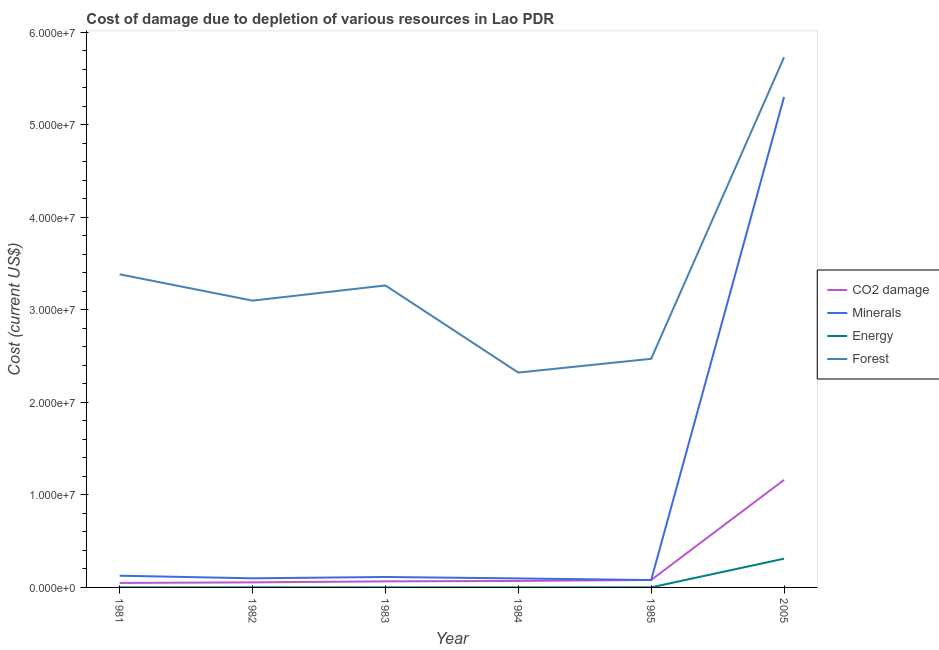How many different coloured lines are there?
Give a very brief answer. 4. Does the line corresponding to cost of damage due to depletion of forests intersect with the line corresponding to cost of damage due to depletion of minerals?
Provide a short and direct response. No. What is the cost of damage due to depletion of minerals in 1985?
Your answer should be very brief. 7.98e+05. Across all years, what is the maximum cost of damage due to depletion of minerals?
Ensure brevity in your answer.  5.30e+07. Across all years, what is the minimum cost of damage due to depletion of minerals?
Give a very brief answer. 7.98e+05. In which year was the cost of damage due to depletion of minerals maximum?
Your answer should be very brief. 2005. In which year was the cost of damage due to depletion of energy minimum?
Your response must be concise. 1981. What is the total cost of damage due to depletion of coal in the graph?
Provide a short and direct response. 1.48e+07. What is the difference between the cost of damage due to depletion of coal in 1984 and that in 2005?
Provide a short and direct response. -1.09e+07. What is the difference between the cost of damage due to depletion of minerals in 1985 and the cost of damage due to depletion of coal in 2005?
Offer a very short reply. -1.08e+07. What is the average cost of damage due to depletion of coal per year?
Offer a terse response. 2.47e+06. In the year 2005, what is the difference between the cost of damage due to depletion of forests and cost of damage due to depletion of coal?
Ensure brevity in your answer.  4.57e+07. What is the ratio of the cost of damage due to depletion of forests in 1983 to that in 1984?
Provide a short and direct response. 1.41. What is the difference between the highest and the second highest cost of damage due to depletion of forests?
Your response must be concise. 2.35e+07. What is the difference between the highest and the lowest cost of damage due to depletion of minerals?
Your response must be concise. 5.22e+07. In how many years, is the cost of damage due to depletion of forests greater than the average cost of damage due to depletion of forests taken over all years?
Offer a terse response. 2. Is the sum of the cost of damage due to depletion of forests in 1985 and 2005 greater than the maximum cost of damage due to depletion of energy across all years?
Your response must be concise. Yes. Is it the case that in every year, the sum of the cost of damage due to depletion of minerals and cost of damage due to depletion of forests is greater than the sum of cost of damage due to depletion of energy and cost of damage due to depletion of coal?
Give a very brief answer. Yes. Does the cost of damage due to depletion of minerals monotonically increase over the years?
Your answer should be very brief. No. Is the cost of damage due to depletion of forests strictly greater than the cost of damage due to depletion of coal over the years?
Give a very brief answer. Yes. How many years are there in the graph?
Give a very brief answer. 6. What is the difference between two consecutive major ticks on the Y-axis?
Your answer should be compact. 1.00e+07. Does the graph contain any zero values?
Your answer should be very brief. No. Where does the legend appear in the graph?
Ensure brevity in your answer.  Center right. How are the legend labels stacked?
Your answer should be very brief. Vertical. What is the title of the graph?
Ensure brevity in your answer.  Cost of damage due to depletion of various resources in Lao PDR . What is the label or title of the X-axis?
Your response must be concise. Year. What is the label or title of the Y-axis?
Provide a succinct answer. Cost (current US$). What is the Cost (current US$) of CO2 damage in 1981?
Your answer should be compact. 4.86e+05. What is the Cost (current US$) of Minerals in 1981?
Provide a succinct answer. 1.27e+06. What is the Cost (current US$) in Energy in 1981?
Offer a very short reply. 1965.83. What is the Cost (current US$) of Forest in 1981?
Offer a very short reply. 3.38e+07. What is the Cost (current US$) in CO2 damage in 1982?
Your response must be concise. 5.48e+05. What is the Cost (current US$) in Minerals in 1982?
Offer a terse response. 9.86e+05. What is the Cost (current US$) of Energy in 1982?
Your answer should be compact. 4233.79. What is the Cost (current US$) in Forest in 1982?
Your answer should be very brief. 3.10e+07. What is the Cost (current US$) in CO2 damage in 1983?
Give a very brief answer. 6.56e+05. What is the Cost (current US$) of Minerals in 1983?
Provide a succinct answer. 1.13e+06. What is the Cost (current US$) of Energy in 1983?
Make the answer very short. 2659.48. What is the Cost (current US$) of Forest in 1983?
Provide a short and direct response. 3.26e+07. What is the Cost (current US$) in CO2 damage in 1984?
Your answer should be very brief. 7.02e+05. What is the Cost (current US$) in Minerals in 1984?
Keep it short and to the point. 9.74e+05. What is the Cost (current US$) of Energy in 1984?
Offer a very short reply. 2016.19. What is the Cost (current US$) in Forest in 1984?
Provide a short and direct response. 2.32e+07. What is the Cost (current US$) of CO2 damage in 1985?
Make the answer very short. 8.06e+05. What is the Cost (current US$) of Minerals in 1985?
Offer a very short reply. 7.98e+05. What is the Cost (current US$) in Energy in 1985?
Provide a succinct answer. 7148.62. What is the Cost (current US$) in Forest in 1985?
Make the answer very short. 2.47e+07. What is the Cost (current US$) of CO2 damage in 2005?
Your answer should be very brief. 1.16e+07. What is the Cost (current US$) in Minerals in 2005?
Provide a short and direct response. 5.30e+07. What is the Cost (current US$) of Energy in 2005?
Your answer should be very brief. 3.11e+06. What is the Cost (current US$) of Forest in 2005?
Make the answer very short. 5.73e+07. Across all years, what is the maximum Cost (current US$) in CO2 damage?
Your answer should be very brief. 1.16e+07. Across all years, what is the maximum Cost (current US$) of Minerals?
Keep it short and to the point. 5.30e+07. Across all years, what is the maximum Cost (current US$) in Energy?
Your response must be concise. 3.11e+06. Across all years, what is the maximum Cost (current US$) of Forest?
Provide a succinct answer. 5.73e+07. Across all years, what is the minimum Cost (current US$) of CO2 damage?
Give a very brief answer. 4.86e+05. Across all years, what is the minimum Cost (current US$) in Minerals?
Keep it short and to the point. 7.98e+05. Across all years, what is the minimum Cost (current US$) in Energy?
Your answer should be compact. 1965.83. Across all years, what is the minimum Cost (current US$) of Forest?
Give a very brief answer. 2.32e+07. What is the total Cost (current US$) of CO2 damage in the graph?
Offer a terse response. 1.48e+07. What is the total Cost (current US$) of Minerals in the graph?
Provide a succinct answer. 5.82e+07. What is the total Cost (current US$) of Energy in the graph?
Your response must be concise. 3.13e+06. What is the total Cost (current US$) in Forest in the graph?
Your response must be concise. 2.03e+08. What is the difference between the Cost (current US$) in CO2 damage in 1981 and that in 1982?
Your response must be concise. -6.17e+04. What is the difference between the Cost (current US$) in Minerals in 1981 and that in 1982?
Ensure brevity in your answer.  2.79e+05. What is the difference between the Cost (current US$) in Energy in 1981 and that in 1982?
Your answer should be compact. -2267.95. What is the difference between the Cost (current US$) of Forest in 1981 and that in 1982?
Offer a terse response. 2.84e+06. What is the difference between the Cost (current US$) of CO2 damage in 1981 and that in 1983?
Your answer should be very brief. -1.70e+05. What is the difference between the Cost (current US$) in Minerals in 1981 and that in 1983?
Your answer should be very brief. 1.36e+05. What is the difference between the Cost (current US$) of Energy in 1981 and that in 1983?
Your answer should be very brief. -693.65. What is the difference between the Cost (current US$) of Forest in 1981 and that in 1983?
Your answer should be very brief. 1.20e+06. What is the difference between the Cost (current US$) in CO2 damage in 1981 and that in 1984?
Your response must be concise. -2.16e+05. What is the difference between the Cost (current US$) in Minerals in 1981 and that in 1984?
Offer a terse response. 2.91e+05. What is the difference between the Cost (current US$) in Energy in 1981 and that in 1984?
Provide a short and direct response. -50.36. What is the difference between the Cost (current US$) in Forest in 1981 and that in 1984?
Your answer should be very brief. 1.06e+07. What is the difference between the Cost (current US$) in CO2 damage in 1981 and that in 1985?
Make the answer very short. -3.20e+05. What is the difference between the Cost (current US$) of Minerals in 1981 and that in 1985?
Your response must be concise. 4.67e+05. What is the difference between the Cost (current US$) in Energy in 1981 and that in 1985?
Keep it short and to the point. -5182.79. What is the difference between the Cost (current US$) of Forest in 1981 and that in 1985?
Make the answer very short. 9.13e+06. What is the difference between the Cost (current US$) in CO2 damage in 1981 and that in 2005?
Make the answer very short. -1.11e+07. What is the difference between the Cost (current US$) in Minerals in 1981 and that in 2005?
Provide a succinct answer. -5.17e+07. What is the difference between the Cost (current US$) of Energy in 1981 and that in 2005?
Offer a terse response. -3.11e+06. What is the difference between the Cost (current US$) in Forest in 1981 and that in 2005?
Your answer should be compact. -2.35e+07. What is the difference between the Cost (current US$) of CO2 damage in 1982 and that in 1983?
Give a very brief answer. -1.09e+05. What is the difference between the Cost (current US$) of Minerals in 1982 and that in 1983?
Offer a very short reply. -1.43e+05. What is the difference between the Cost (current US$) in Energy in 1982 and that in 1983?
Keep it short and to the point. 1574.31. What is the difference between the Cost (current US$) of Forest in 1982 and that in 1983?
Your response must be concise. -1.64e+06. What is the difference between the Cost (current US$) of CO2 damage in 1982 and that in 1984?
Keep it short and to the point. -1.54e+05. What is the difference between the Cost (current US$) of Minerals in 1982 and that in 1984?
Provide a short and direct response. 1.22e+04. What is the difference between the Cost (current US$) of Energy in 1982 and that in 1984?
Keep it short and to the point. 2217.6. What is the difference between the Cost (current US$) of Forest in 1982 and that in 1984?
Your answer should be compact. 7.78e+06. What is the difference between the Cost (current US$) of CO2 damage in 1982 and that in 1985?
Your answer should be very brief. -2.58e+05. What is the difference between the Cost (current US$) of Minerals in 1982 and that in 1985?
Ensure brevity in your answer.  1.88e+05. What is the difference between the Cost (current US$) of Energy in 1982 and that in 1985?
Give a very brief answer. -2914.84. What is the difference between the Cost (current US$) in Forest in 1982 and that in 1985?
Provide a short and direct response. 6.29e+06. What is the difference between the Cost (current US$) of CO2 damage in 1982 and that in 2005?
Provide a short and direct response. -1.11e+07. What is the difference between the Cost (current US$) of Minerals in 1982 and that in 2005?
Offer a terse response. -5.20e+07. What is the difference between the Cost (current US$) of Energy in 1982 and that in 2005?
Provide a short and direct response. -3.10e+06. What is the difference between the Cost (current US$) of Forest in 1982 and that in 2005?
Make the answer very short. -2.63e+07. What is the difference between the Cost (current US$) of CO2 damage in 1983 and that in 1984?
Provide a short and direct response. -4.53e+04. What is the difference between the Cost (current US$) in Minerals in 1983 and that in 1984?
Your answer should be compact. 1.55e+05. What is the difference between the Cost (current US$) in Energy in 1983 and that in 1984?
Make the answer very short. 643.29. What is the difference between the Cost (current US$) in Forest in 1983 and that in 1984?
Provide a succinct answer. 9.42e+06. What is the difference between the Cost (current US$) of CO2 damage in 1983 and that in 1985?
Ensure brevity in your answer.  -1.50e+05. What is the difference between the Cost (current US$) in Minerals in 1983 and that in 1985?
Your answer should be compact. 3.31e+05. What is the difference between the Cost (current US$) in Energy in 1983 and that in 1985?
Make the answer very short. -4489.14. What is the difference between the Cost (current US$) in Forest in 1983 and that in 1985?
Give a very brief answer. 7.93e+06. What is the difference between the Cost (current US$) of CO2 damage in 1983 and that in 2005?
Give a very brief answer. -1.10e+07. What is the difference between the Cost (current US$) in Minerals in 1983 and that in 2005?
Offer a terse response. -5.19e+07. What is the difference between the Cost (current US$) of Energy in 1983 and that in 2005?
Your answer should be compact. -3.10e+06. What is the difference between the Cost (current US$) of Forest in 1983 and that in 2005?
Offer a terse response. -2.47e+07. What is the difference between the Cost (current US$) in CO2 damage in 1984 and that in 1985?
Your answer should be compact. -1.04e+05. What is the difference between the Cost (current US$) of Minerals in 1984 and that in 1985?
Give a very brief answer. 1.76e+05. What is the difference between the Cost (current US$) of Energy in 1984 and that in 1985?
Your answer should be compact. -5132.43. What is the difference between the Cost (current US$) in Forest in 1984 and that in 1985?
Give a very brief answer. -1.49e+06. What is the difference between the Cost (current US$) in CO2 damage in 1984 and that in 2005?
Keep it short and to the point. -1.09e+07. What is the difference between the Cost (current US$) in Minerals in 1984 and that in 2005?
Keep it short and to the point. -5.20e+07. What is the difference between the Cost (current US$) of Energy in 1984 and that in 2005?
Provide a succinct answer. -3.11e+06. What is the difference between the Cost (current US$) of Forest in 1984 and that in 2005?
Provide a succinct answer. -3.41e+07. What is the difference between the Cost (current US$) in CO2 damage in 1985 and that in 2005?
Keep it short and to the point. -1.08e+07. What is the difference between the Cost (current US$) of Minerals in 1985 and that in 2005?
Your response must be concise. -5.22e+07. What is the difference between the Cost (current US$) in Energy in 1985 and that in 2005?
Your answer should be compact. -3.10e+06. What is the difference between the Cost (current US$) of Forest in 1985 and that in 2005?
Offer a terse response. -3.26e+07. What is the difference between the Cost (current US$) in CO2 damage in 1981 and the Cost (current US$) in Minerals in 1982?
Offer a very short reply. -5.00e+05. What is the difference between the Cost (current US$) in CO2 damage in 1981 and the Cost (current US$) in Energy in 1982?
Your answer should be compact. 4.82e+05. What is the difference between the Cost (current US$) in CO2 damage in 1981 and the Cost (current US$) in Forest in 1982?
Your answer should be compact. -3.05e+07. What is the difference between the Cost (current US$) in Minerals in 1981 and the Cost (current US$) in Energy in 1982?
Your answer should be very brief. 1.26e+06. What is the difference between the Cost (current US$) in Minerals in 1981 and the Cost (current US$) in Forest in 1982?
Keep it short and to the point. -2.97e+07. What is the difference between the Cost (current US$) of Energy in 1981 and the Cost (current US$) of Forest in 1982?
Offer a terse response. -3.10e+07. What is the difference between the Cost (current US$) in CO2 damage in 1981 and the Cost (current US$) in Minerals in 1983?
Provide a succinct answer. -6.43e+05. What is the difference between the Cost (current US$) in CO2 damage in 1981 and the Cost (current US$) in Energy in 1983?
Your answer should be compact. 4.83e+05. What is the difference between the Cost (current US$) in CO2 damage in 1981 and the Cost (current US$) in Forest in 1983?
Your answer should be compact. -3.22e+07. What is the difference between the Cost (current US$) of Minerals in 1981 and the Cost (current US$) of Energy in 1983?
Your answer should be very brief. 1.26e+06. What is the difference between the Cost (current US$) in Minerals in 1981 and the Cost (current US$) in Forest in 1983?
Your answer should be compact. -3.14e+07. What is the difference between the Cost (current US$) in Energy in 1981 and the Cost (current US$) in Forest in 1983?
Make the answer very short. -3.26e+07. What is the difference between the Cost (current US$) of CO2 damage in 1981 and the Cost (current US$) of Minerals in 1984?
Give a very brief answer. -4.88e+05. What is the difference between the Cost (current US$) of CO2 damage in 1981 and the Cost (current US$) of Energy in 1984?
Keep it short and to the point. 4.84e+05. What is the difference between the Cost (current US$) of CO2 damage in 1981 and the Cost (current US$) of Forest in 1984?
Your answer should be very brief. -2.27e+07. What is the difference between the Cost (current US$) in Minerals in 1981 and the Cost (current US$) in Energy in 1984?
Your answer should be very brief. 1.26e+06. What is the difference between the Cost (current US$) in Minerals in 1981 and the Cost (current US$) in Forest in 1984?
Offer a terse response. -2.20e+07. What is the difference between the Cost (current US$) of Energy in 1981 and the Cost (current US$) of Forest in 1984?
Keep it short and to the point. -2.32e+07. What is the difference between the Cost (current US$) in CO2 damage in 1981 and the Cost (current US$) in Minerals in 1985?
Offer a terse response. -3.12e+05. What is the difference between the Cost (current US$) in CO2 damage in 1981 and the Cost (current US$) in Energy in 1985?
Offer a terse response. 4.79e+05. What is the difference between the Cost (current US$) in CO2 damage in 1981 and the Cost (current US$) in Forest in 1985?
Ensure brevity in your answer.  -2.42e+07. What is the difference between the Cost (current US$) of Minerals in 1981 and the Cost (current US$) of Energy in 1985?
Provide a succinct answer. 1.26e+06. What is the difference between the Cost (current US$) of Minerals in 1981 and the Cost (current US$) of Forest in 1985?
Ensure brevity in your answer.  -2.34e+07. What is the difference between the Cost (current US$) in Energy in 1981 and the Cost (current US$) in Forest in 1985?
Your answer should be very brief. -2.47e+07. What is the difference between the Cost (current US$) of CO2 damage in 1981 and the Cost (current US$) of Minerals in 2005?
Your answer should be compact. -5.25e+07. What is the difference between the Cost (current US$) in CO2 damage in 1981 and the Cost (current US$) in Energy in 2005?
Your response must be concise. -2.62e+06. What is the difference between the Cost (current US$) in CO2 damage in 1981 and the Cost (current US$) in Forest in 2005?
Ensure brevity in your answer.  -5.68e+07. What is the difference between the Cost (current US$) of Minerals in 1981 and the Cost (current US$) of Energy in 2005?
Provide a short and direct response. -1.84e+06. What is the difference between the Cost (current US$) in Minerals in 1981 and the Cost (current US$) in Forest in 2005?
Offer a very short reply. -5.60e+07. What is the difference between the Cost (current US$) of Energy in 1981 and the Cost (current US$) of Forest in 2005?
Your response must be concise. -5.73e+07. What is the difference between the Cost (current US$) in CO2 damage in 1982 and the Cost (current US$) in Minerals in 1983?
Provide a succinct answer. -5.81e+05. What is the difference between the Cost (current US$) in CO2 damage in 1982 and the Cost (current US$) in Energy in 1983?
Your answer should be compact. 5.45e+05. What is the difference between the Cost (current US$) of CO2 damage in 1982 and the Cost (current US$) of Forest in 1983?
Ensure brevity in your answer.  -3.21e+07. What is the difference between the Cost (current US$) in Minerals in 1982 and the Cost (current US$) in Energy in 1983?
Provide a short and direct response. 9.83e+05. What is the difference between the Cost (current US$) in Minerals in 1982 and the Cost (current US$) in Forest in 1983?
Provide a short and direct response. -3.17e+07. What is the difference between the Cost (current US$) in Energy in 1982 and the Cost (current US$) in Forest in 1983?
Your answer should be very brief. -3.26e+07. What is the difference between the Cost (current US$) in CO2 damage in 1982 and the Cost (current US$) in Minerals in 1984?
Your answer should be very brief. -4.26e+05. What is the difference between the Cost (current US$) in CO2 damage in 1982 and the Cost (current US$) in Energy in 1984?
Your answer should be very brief. 5.46e+05. What is the difference between the Cost (current US$) in CO2 damage in 1982 and the Cost (current US$) in Forest in 1984?
Give a very brief answer. -2.27e+07. What is the difference between the Cost (current US$) in Minerals in 1982 and the Cost (current US$) in Energy in 1984?
Offer a terse response. 9.84e+05. What is the difference between the Cost (current US$) in Minerals in 1982 and the Cost (current US$) in Forest in 1984?
Your answer should be very brief. -2.22e+07. What is the difference between the Cost (current US$) in Energy in 1982 and the Cost (current US$) in Forest in 1984?
Give a very brief answer. -2.32e+07. What is the difference between the Cost (current US$) of CO2 damage in 1982 and the Cost (current US$) of Minerals in 1985?
Your answer should be compact. -2.50e+05. What is the difference between the Cost (current US$) in CO2 damage in 1982 and the Cost (current US$) in Energy in 1985?
Give a very brief answer. 5.40e+05. What is the difference between the Cost (current US$) of CO2 damage in 1982 and the Cost (current US$) of Forest in 1985?
Keep it short and to the point. -2.42e+07. What is the difference between the Cost (current US$) in Minerals in 1982 and the Cost (current US$) in Energy in 1985?
Give a very brief answer. 9.79e+05. What is the difference between the Cost (current US$) of Minerals in 1982 and the Cost (current US$) of Forest in 1985?
Keep it short and to the point. -2.37e+07. What is the difference between the Cost (current US$) of Energy in 1982 and the Cost (current US$) of Forest in 1985?
Keep it short and to the point. -2.47e+07. What is the difference between the Cost (current US$) in CO2 damage in 1982 and the Cost (current US$) in Minerals in 2005?
Offer a very short reply. -5.25e+07. What is the difference between the Cost (current US$) in CO2 damage in 1982 and the Cost (current US$) in Energy in 2005?
Provide a short and direct response. -2.56e+06. What is the difference between the Cost (current US$) in CO2 damage in 1982 and the Cost (current US$) in Forest in 2005?
Offer a terse response. -5.68e+07. What is the difference between the Cost (current US$) of Minerals in 1982 and the Cost (current US$) of Energy in 2005?
Your answer should be very brief. -2.12e+06. What is the difference between the Cost (current US$) of Minerals in 1982 and the Cost (current US$) of Forest in 2005?
Offer a terse response. -5.63e+07. What is the difference between the Cost (current US$) in Energy in 1982 and the Cost (current US$) in Forest in 2005?
Offer a very short reply. -5.73e+07. What is the difference between the Cost (current US$) of CO2 damage in 1983 and the Cost (current US$) of Minerals in 1984?
Provide a short and direct response. -3.17e+05. What is the difference between the Cost (current US$) in CO2 damage in 1983 and the Cost (current US$) in Energy in 1984?
Provide a short and direct response. 6.54e+05. What is the difference between the Cost (current US$) of CO2 damage in 1983 and the Cost (current US$) of Forest in 1984?
Offer a very short reply. -2.26e+07. What is the difference between the Cost (current US$) in Minerals in 1983 and the Cost (current US$) in Energy in 1984?
Provide a succinct answer. 1.13e+06. What is the difference between the Cost (current US$) in Minerals in 1983 and the Cost (current US$) in Forest in 1984?
Provide a succinct answer. -2.21e+07. What is the difference between the Cost (current US$) of Energy in 1983 and the Cost (current US$) of Forest in 1984?
Ensure brevity in your answer.  -2.32e+07. What is the difference between the Cost (current US$) in CO2 damage in 1983 and the Cost (current US$) in Minerals in 1985?
Offer a terse response. -1.41e+05. What is the difference between the Cost (current US$) in CO2 damage in 1983 and the Cost (current US$) in Energy in 1985?
Give a very brief answer. 6.49e+05. What is the difference between the Cost (current US$) in CO2 damage in 1983 and the Cost (current US$) in Forest in 1985?
Your answer should be compact. -2.41e+07. What is the difference between the Cost (current US$) of Minerals in 1983 and the Cost (current US$) of Energy in 1985?
Provide a short and direct response. 1.12e+06. What is the difference between the Cost (current US$) of Minerals in 1983 and the Cost (current US$) of Forest in 1985?
Provide a short and direct response. -2.36e+07. What is the difference between the Cost (current US$) of Energy in 1983 and the Cost (current US$) of Forest in 1985?
Make the answer very short. -2.47e+07. What is the difference between the Cost (current US$) of CO2 damage in 1983 and the Cost (current US$) of Minerals in 2005?
Offer a terse response. -5.24e+07. What is the difference between the Cost (current US$) of CO2 damage in 1983 and the Cost (current US$) of Energy in 2005?
Your response must be concise. -2.45e+06. What is the difference between the Cost (current US$) of CO2 damage in 1983 and the Cost (current US$) of Forest in 2005?
Provide a short and direct response. -5.66e+07. What is the difference between the Cost (current US$) of Minerals in 1983 and the Cost (current US$) of Energy in 2005?
Give a very brief answer. -1.98e+06. What is the difference between the Cost (current US$) in Minerals in 1983 and the Cost (current US$) in Forest in 2005?
Your answer should be compact. -5.62e+07. What is the difference between the Cost (current US$) of Energy in 1983 and the Cost (current US$) of Forest in 2005?
Provide a succinct answer. -5.73e+07. What is the difference between the Cost (current US$) of CO2 damage in 1984 and the Cost (current US$) of Minerals in 1985?
Your answer should be very brief. -9.61e+04. What is the difference between the Cost (current US$) in CO2 damage in 1984 and the Cost (current US$) in Energy in 1985?
Provide a succinct answer. 6.94e+05. What is the difference between the Cost (current US$) of CO2 damage in 1984 and the Cost (current US$) of Forest in 1985?
Provide a succinct answer. -2.40e+07. What is the difference between the Cost (current US$) of Minerals in 1984 and the Cost (current US$) of Energy in 1985?
Offer a very short reply. 9.67e+05. What is the difference between the Cost (current US$) in Minerals in 1984 and the Cost (current US$) in Forest in 1985?
Your answer should be compact. -2.37e+07. What is the difference between the Cost (current US$) in Energy in 1984 and the Cost (current US$) in Forest in 1985?
Your response must be concise. -2.47e+07. What is the difference between the Cost (current US$) of CO2 damage in 1984 and the Cost (current US$) of Minerals in 2005?
Offer a very short reply. -5.23e+07. What is the difference between the Cost (current US$) in CO2 damage in 1984 and the Cost (current US$) in Energy in 2005?
Keep it short and to the point. -2.41e+06. What is the difference between the Cost (current US$) in CO2 damage in 1984 and the Cost (current US$) in Forest in 2005?
Ensure brevity in your answer.  -5.66e+07. What is the difference between the Cost (current US$) in Minerals in 1984 and the Cost (current US$) in Energy in 2005?
Provide a succinct answer. -2.13e+06. What is the difference between the Cost (current US$) of Minerals in 1984 and the Cost (current US$) of Forest in 2005?
Your response must be concise. -5.63e+07. What is the difference between the Cost (current US$) of Energy in 1984 and the Cost (current US$) of Forest in 2005?
Your answer should be compact. -5.73e+07. What is the difference between the Cost (current US$) of CO2 damage in 1985 and the Cost (current US$) of Minerals in 2005?
Your answer should be compact. -5.22e+07. What is the difference between the Cost (current US$) in CO2 damage in 1985 and the Cost (current US$) in Energy in 2005?
Make the answer very short. -2.30e+06. What is the difference between the Cost (current US$) of CO2 damage in 1985 and the Cost (current US$) of Forest in 2005?
Make the answer very short. -5.65e+07. What is the difference between the Cost (current US$) in Minerals in 1985 and the Cost (current US$) in Energy in 2005?
Offer a terse response. -2.31e+06. What is the difference between the Cost (current US$) in Minerals in 1985 and the Cost (current US$) in Forest in 2005?
Ensure brevity in your answer.  -5.65e+07. What is the difference between the Cost (current US$) in Energy in 1985 and the Cost (current US$) in Forest in 2005?
Provide a short and direct response. -5.73e+07. What is the average Cost (current US$) in CO2 damage per year?
Ensure brevity in your answer.  2.47e+06. What is the average Cost (current US$) of Minerals per year?
Keep it short and to the point. 9.69e+06. What is the average Cost (current US$) in Energy per year?
Your answer should be very brief. 5.21e+05. What is the average Cost (current US$) in Forest per year?
Provide a succinct answer. 3.38e+07. In the year 1981, what is the difference between the Cost (current US$) in CO2 damage and Cost (current US$) in Minerals?
Provide a succinct answer. -7.79e+05. In the year 1981, what is the difference between the Cost (current US$) in CO2 damage and Cost (current US$) in Energy?
Keep it short and to the point. 4.84e+05. In the year 1981, what is the difference between the Cost (current US$) in CO2 damage and Cost (current US$) in Forest?
Give a very brief answer. -3.34e+07. In the year 1981, what is the difference between the Cost (current US$) of Minerals and Cost (current US$) of Energy?
Keep it short and to the point. 1.26e+06. In the year 1981, what is the difference between the Cost (current US$) in Minerals and Cost (current US$) in Forest?
Provide a short and direct response. -3.26e+07. In the year 1981, what is the difference between the Cost (current US$) in Energy and Cost (current US$) in Forest?
Provide a short and direct response. -3.38e+07. In the year 1982, what is the difference between the Cost (current US$) in CO2 damage and Cost (current US$) in Minerals?
Make the answer very short. -4.38e+05. In the year 1982, what is the difference between the Cost (current US$) of CO2 damage and Cost (current US$) of Energy?
Offer a very short reply. 5.43e+05. In the year 1982, what is the difference between the Cost (current US$) in CO2 damage and Cost (current US$) in Forest?
Provide a succinct answer. -3.05e+07. In the year 1982, what is the difference between the Cost (current US$) in Minerals and Cost (current US$) in Energy?
Offer a terse response. 9.82e+05. In the year 1982, what is the difference between the Cost (current US$) of Minerals and Cost (current US$) of Forest?
Offer a terse response. -3.00e+07. In the year 1982, what is the difference between the Cost (current US$) in Energy and Cost (current US$) in Forest?
Your response must be concise. -3.10e+07. In the year 1983, what is the difference between the Cost (current US$) in CO2 damage and Cost (current US$) in Minerals?
Provide a short and direct response. -4.73e+05. In the year 1983, what is the difference between the Cost (current US$) of CO2 damage and Cost (current US$) of Energy?
Offer a very short reply. 6.54e+05. In the year 1983, what is the difference between the Cost (current US$) of CO2 damage and Cost (current US$) of Forest?
Make the answer very short. -3.20e+07. In the year 1983, what is the difference between the Cost (current US$) in Minerals and Cost (current US$) in Energy?
Offer a terse response. 1.13e+06. In the year 1983, what is the difference between the Cost (current US$) of Minerals and Cost (current US$) of Forest?
Keep it short and to the point. -3.15e+07. In the year 1983, what is the difference between the Cost (current US$) in Energy and Cost (current US$) in Forest?
Your answer should be compact. -3.26e+07. In the year 1984, what is the difference between the Cost (current US$) in CO2 damage and Cost (current US$) in Minerals?
Offer a very short reply. -2.72e+05. In the year 1984, what is the difference between the Cost (current US$) in CO2 damage and Cost (current US$) in Energy?
Your answer should be compact. 7.00e+05. In the year 1984, what is the difference between the Cost (current US$) of CO2 damage and Cost (current US$) of Forest?
Provide a short and direct response. -2.25e+07. In the year 1984, what is the difference between the Cost (current US$) of Minerals and Cost (current US$) of Energy?
Your answer should be very brief. 9.72e+05. In the year 1984, what is the difference between the Cost (current US$) in Minerals and Cost (current US$) in Forest?
Your response must be concise. -2.23e+07. In the year 1984, what is the difference between the Cost (current US$) in Energy and Cost (current US$) in Forest?
Give a very brief answer. -2.32e+07. In the year 1985, what is the difference between the Cost (current US$) in CO2 damage and Cost (current US$) in Minerals?
Your answer should be compact. 8139.44. In the year 1985, what is the difference between the Cost (current US$) in CO2 damage and Cost (current US$) in Energy?
Provide a succinct answer. 7.99e+05. In the year 1985, what is the difference between the Cost (current US$) in CO2 damage and Cost (current US$) in Forest?
Keep it short and to the point. -2.39e+07. In the year 1985, what is the difference between the Cost (current US$) in Minerals and Cost (current US$) in Energy?
Give a very brief answer. 7.91e+05. In the year 1985, what is the difference between the Cost (current US$) of Minerals and Cost (current US$) of Forest?
Your answer should be very brief. -2.39e+07. In the year 1985, what is the difference between the Cost (current US$) in Energy and Cost (current US$) in Forest?
Your answer should be very brief. -2.47e+07. In the year 2005, what is the difference between the Cost (current US$) in CO2 damage and Cost (current US$) in Minerals?
Offer a very short reply. -4.14e+07. In the year 2005, what is the difference between the Cost (current US$) in CO2 damage and Cost (current US$) in Energy?
Keep it short and to the point. 8.51e+06. In the year 2005, what is the difference between the Cost (current US$) in CO2 damage and Cost (current US$) in Forest?
Provide a succinct answer. -4.57e+07. In the year 2005, what is the difference between the Cost (current US$) of Minerals and Cost (current US$) of Energy?
Your answer should be very brief. 4.99e+07. In the year 2005, what is the difference between the Cost (current US$) of Minerals and Cost (current US$) of Forest?
Ensure brevity in your answer.  -4.29e+06. In the year 2005, what is the difference between the Cost (current US$) of Energy and Cost (current US$) of Forest?
Provide a short and direct response. -5.42e+07. What is the ratio of the Cost (current US$) in CO2 damage in 1981 to that in 1982?
Keep it short and to the point. 0.89. What is the ratio of the Cost (current US$) of Minerals in 1981 to that in 1982?
Your answer should be very brief. 1.28. What is the ratio of the Cost (current US$) of Energy in 1981 to that in 1982?
Offer a very short reply. 0.46. What is the ratio of the Cost (current US$) in Forest in 1981 to that in 1982?
Your answer should be compact. 1.09. What is the ratio of the Cost (current US$) of CO2 damage in 1981 to that in 1983?
Your answer should be very brief. 0.74. What is the ratio of the Cost (current US$) of Minerals in 1981 to that in 1983?
Offer a terse response. 1.12. What is the ratio of the Cost (current US$) in Energy in 1981 to that in 1983?
Offer a terse response. 0.74. What is the ratio of the Cost (current US$) in Forest in 1981 to that in 1983?
Provide a succinct answer. 1.04. What is the ratio of the Cost (current US$) of CO2 damage in 1981 to that in 1984?
Give a very brief answer. 0.69. What is the ratio of the Cost (current US$) of Minerals in 1981 to that in 1984?
Your answer should be very brief. 1.3. What is the ratio of the Cost (current US$) in Energy in 1981 to that in 1984?
Keep it short and to the point. 0.97. What is the ratio of the Cost (current US$) of Forest in 1981 to that in 1984?
Provide a short and direct response. 1.46. What is the ratio of the Cost (current US$) of CO2 damage in 1981 to that in 1985?
Offer a very short reply. 0.6. What is the ratio of the Cost (current US$) in Minerals in 1981 to that in 1985?
Ensure brevity in your answer.  1.59. What is the ratio of the Cost (current US$) in Energy in 1981 to that in 1985?
Keep it short and to the point. 0.28. What is the ratio of the Cost (current US$) in Forest in 1981 to that in 1985?
Your answer should be compact. 1.37. What is the ratio of the Cost (current US$) of CO2 damage in 1981 to that in 2005?
Your response must be concise. 0.04. What is the ratio of the Cost (current US$) of Minerals in 1981 to that in 2005?
Provide a succinct answer. 0.02. What is the ratio of the Cost (current US$) in Energy in 1981 to that in 2005?
Provide a succinct answer. 0. What is the ratio of the Cost (current US$) of Forest in 1981 to that in 2005?
Provide a succinct answer. 0.59. What is the ratio of the Cost (current US$) in CO2 damage in 1982 to that in 1983?
Offer a terse response. 0.83. What is the ratio of the Cost (current US$) of Minerals in 1982 to that in 1983?
Offer a very short reply. 0.87. What is the ratio of the Cost (current US$) of Energy in 1982 to that in 1983?
Your response must be concise. 1.59. What is the ratio of the Cost (current US$) of Forest in 1982 to that in 1983?
Your answer should be compact. 0.95. What is the ratio of the Cost (current US$) of CO2 damage in 1982 to that in 1984?
Make the answer very short. 0.78. What is the ratio of the Cost (current US$) in Minerals in 1982 to that in 1984?
Offer a very short reply. 1.01. What is the ratio of the Cost (current US$) of Energy in 1982 to that in 1984?
Provide a short and direct response. 2.1. What is the ratio of the Cost (current US$) of Forest in 1982 to that in 1984?
Your response must be concise. 1.33. What is the ratio of the Cost (current US$) in CO2 damage in 1982 to that in 1985?
Give a very brief answer. 0.68. What is the ratio of the Cost (current US$) of Minerals in 1982 to that in 1985?
Ensure brevity in your answer.  1.24. What is the ratio of the Cost (current US$) of Energy in 1982 to that in 1985?
Provide a short and direct response. 0.59. What is the ratio of the Cost (current US$) in Forest in 1982 to that in 1985?
Your answer should be compact. 1.25. What is the ratio of the Cost (current US$) in CO2 damage in 1982 to that in 2005?
Provide a short and direct response. 0.05. What is the ratio of the Cost (current US$) in Minerals in 1982 to that in 2005?
Offer a terse response. 0.02. What is the ratio of the Cost (current US$) in Energy in 1982 to that in 2005?
Provide a short and direct response. 0. What is the ratio of the Cost (current US$) of Forest in 1982 to that in 2005?
Offer a very short reply. 0.54. What is the ratio of the Cost (current US$) in CO2 damage in 1983 to that in 1984?
Your response must be concise. 0.94. What is the ratio of the Cost (current US$) in Minerals in 1983 to that in 1984?
Keep it short and to the point. 1.16. What is the ratio of the Cost (current US$) in Energy in 1983 to that in 1984?
Provide a succinct answer. 1.32. What is the ratio of the Cost (current US$) of Forest in 1983 to that in 1984?
Your response must be concise. 1.41. What is the ratio of the Cost (current US$) of CO2 damage in 1983 to that in 1985?
Offer a very short reply. 0.81. What is the ratio of the Cost (current US$) in Minerals in 1983 to that in 1985?
Your answer should be very brief. 1.42. What is the ratio of the Cost (current US$) of Energy in 1983 to that in 1985?
Ensure brevity in your answer.  0.37. What is the ratio of the Cost (current US$) of Forest in 1983 to that in 1985?
Keep it short and to the point. 1.32. What is the ratio of the Cost (current US$) in CO2 damage in 1983 to that in 2005?
Your answer should be very brief. 0.06. What is the ratio of the Cost (current US$) in Minerals in 1983 to that in 2005?
Keep it short and to the point. 0.02. What is the ratio of the Cost (current US$) of Energy in 1983 to that in 2005?
Give a very brief answer. 0. What is the ratio of the Cost (current US$) of Forest in 1983 to that in 2005?
Your response must be concise. 0.57. What is the ratio of the Cost (current US$) in CO2 damage in 1984 to that in 1985?
Your answer should be very brief. 0.87. What is the ratio of the Cost (current US$) in Minerals in 1984 to that in 1985?
Your answer should be very brief. 1.22. What is the ratio of the Cost (current US$) in Energy in 1984 to that in 1985?
Your answer should be very brief. 0.28. What is the ratio of the Cost (current US$) of Forest in 1984 to that in 1985?
Offer a very short reply. 0.94. What is the ratio of the Cost (current US$) of CO2 damage in 1984 to that in 2005?
Make the answer very short. 0.06. What is the ratio of the Cost (current US$) of Minerals in 1984 to that in 2005?
Keep it short and to the point. 0.02. What is the ratio of the Cost (current US$) in Energy in 1984 to that in 2005?
Offer a very short reply. 0. What is the ratio of the Cost (current US$) in Forest in 1984 to that in 2005?
Provide a succinct answer. 0.41. What is the ratio of the Cost (current US$) of CO2 damage in 1985 to that in 2005?
Provide a short and direct response. 0.07. What is the ratio of the Cost (current US$) in Minerals in 1985 to that in 2005?
Your response must be concise. 0.01. What is the ratio of the Cost (current US$) in Energy in 1985 to that in 2005?
Give a very brief answer. 0. What is the ratio of the Cost (current US$) in Forest in 1985 to that in 2005?
Your answer should be compact. 0.43. What is the difference between the highest and the second highest Cost (current US$) of CO2 damage?
Your response must be concise. 1.08e+07. What is the difference between the highest and the second highest Cost (current US$) in Minerals?
Make the answer very short. 5.17e+07. What is the difference between the highest and the second highest Cost (current US$) of Energy?
Keep it short and to the point. 3.10e+06. What is the difference between the highest and the second highest Cost (current US$) of Forest?
Your answer should be compact. 2.35e+07. What is the difference between the highest and the lowest Cost (current US$) in CO2 damage?
Offer a very short reply. 1.11e+07. What is the difference between the highest and the lowest Cost (current US$) of Minerals?
Your answer should be very brief. 5.22e+07. What is the difference between the highest and the lowest Cost (current US$) of Energy?
Keep it short and to the point. 3.11e+06. What is the difference between the highest and the lowest Cost (current US$) of Forest?
Your answer should be compact. 3.41e+07. 